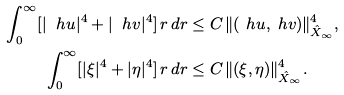Convert formula to latex. <formula><loc_0><loc_0><loc_500><loc_500>\int _ { 0 } ^ { \infty } [ | \ h u | ^ { 4 } + | \ h v | ^ { 4 } ] \, r \, d r & \leq C \, \| ( \ h u , \ h v ) \| _ { \hat { X } _ { \infty } } ^ { 4 } , \\ \int _ { 0 } ^ { \infty } [ | \xi | ^ { 4 } + | \eta | ^ { 4 } ] \, r \, d r & \leq C \, \| ( \xi , \eta ) \| _ { \hat { X } _ { \infty } } ^ { 4 } .</formula> 